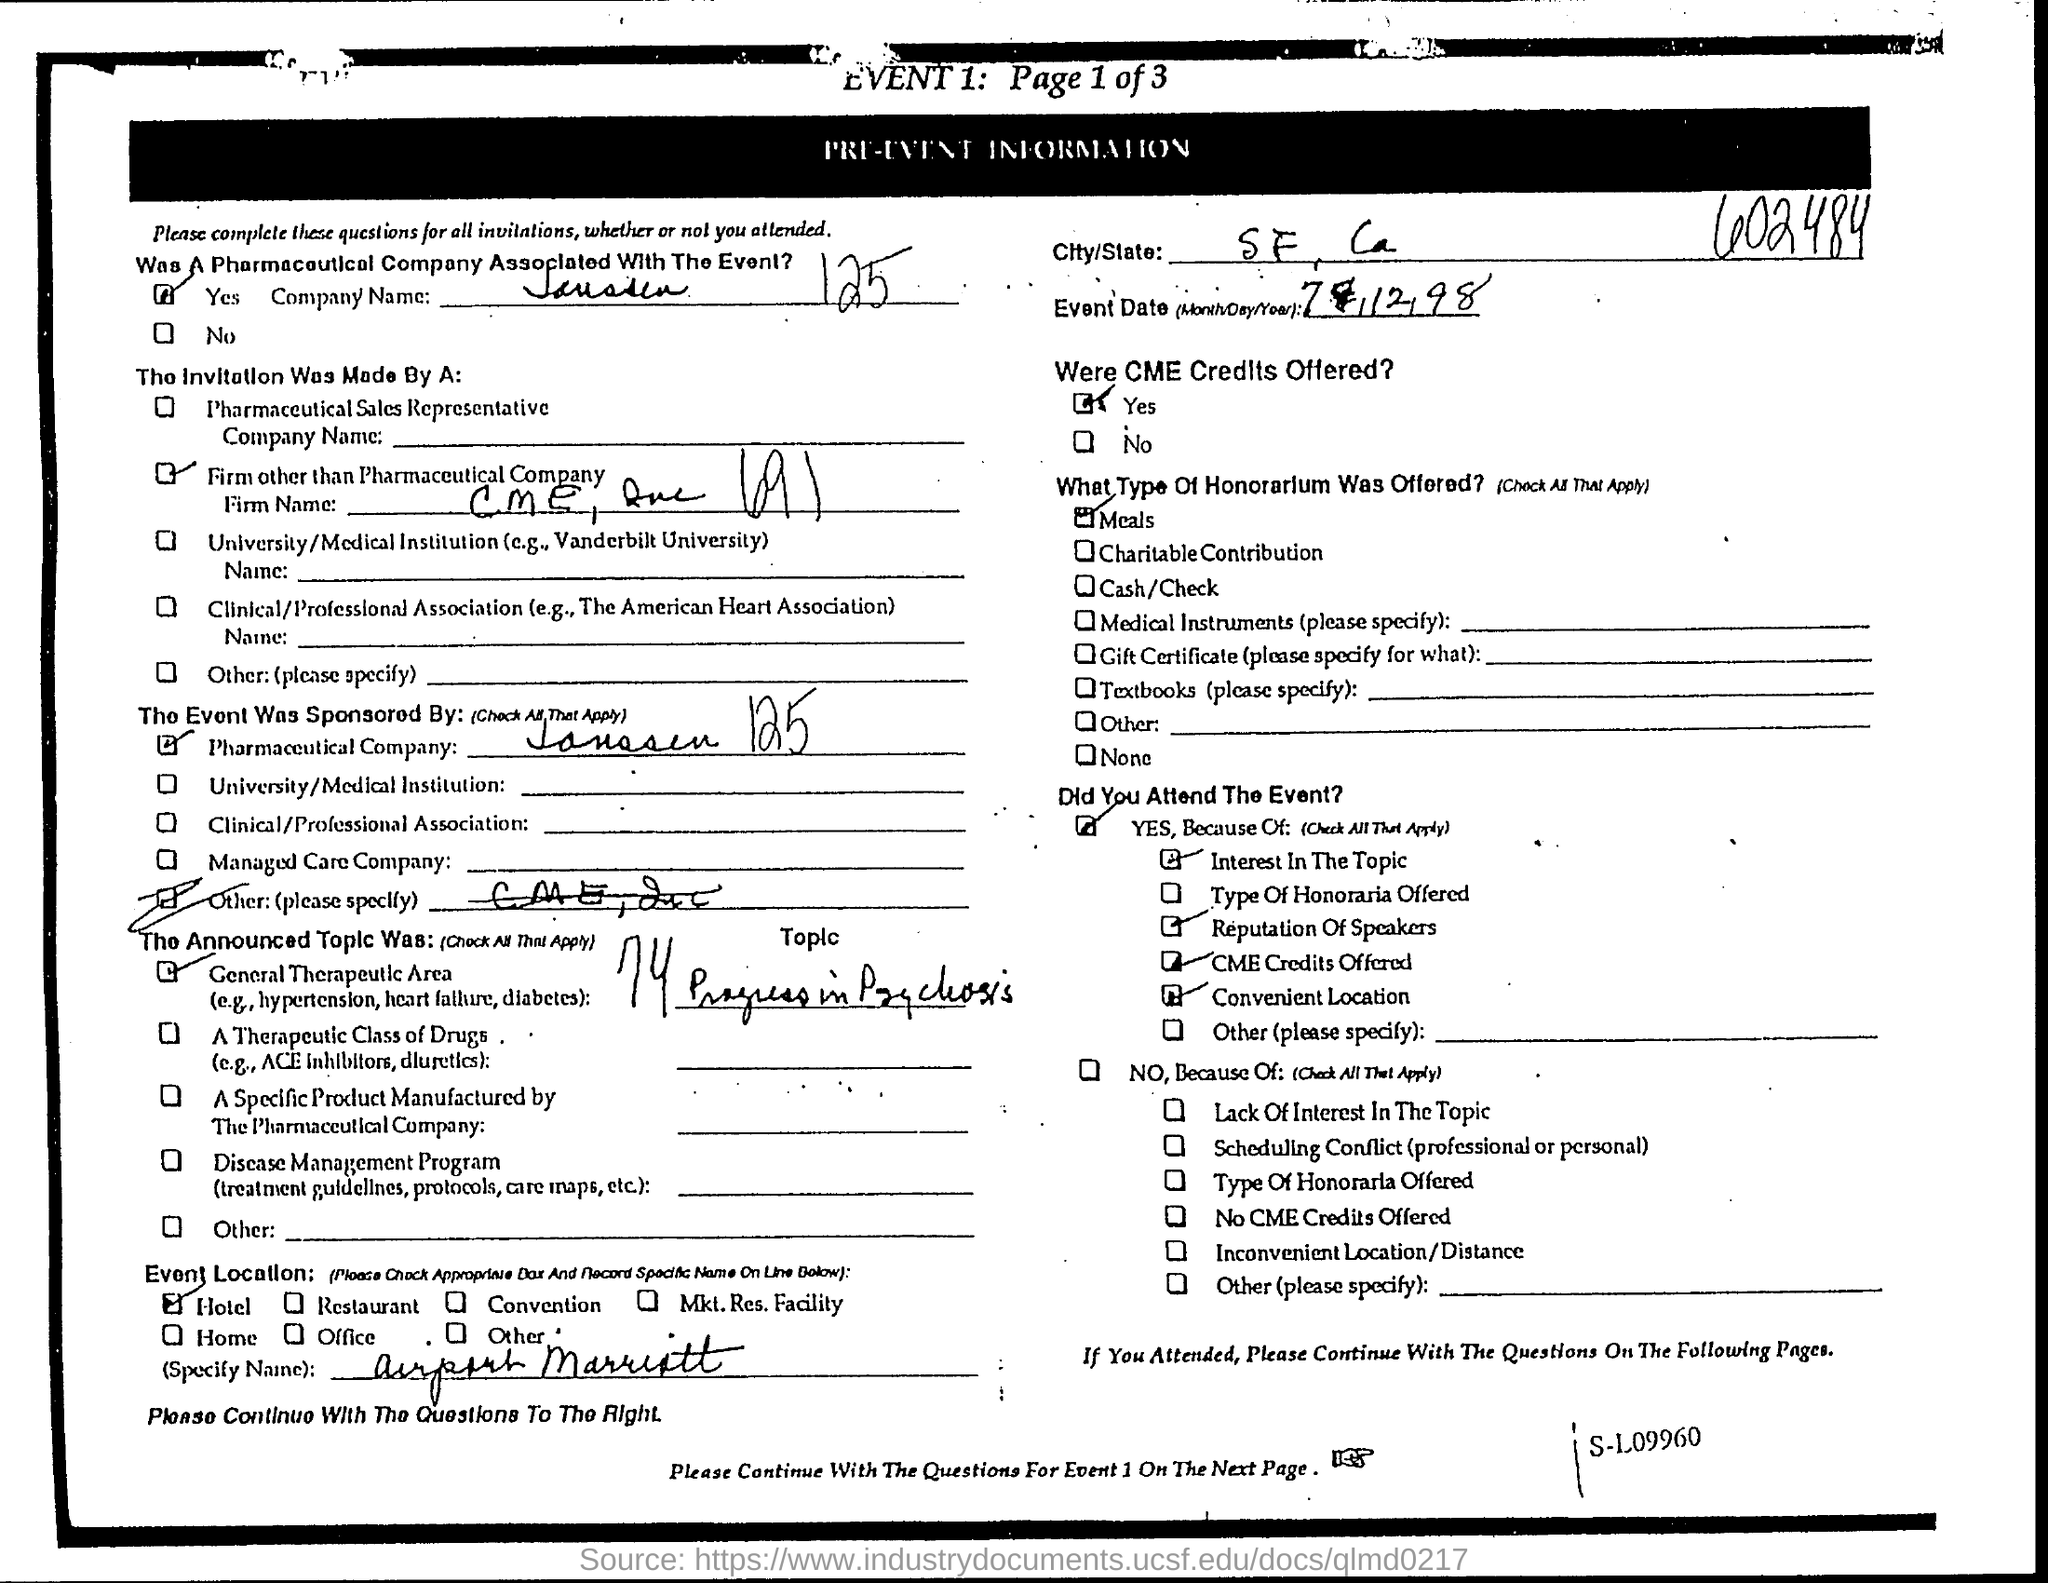Indicate a few pertinent items in this graphic. The Honorarium offered include meals. The page number provided is page 1 of 3. The city is San Francisco, located in the state of California. What is the event number?" is a question asking for information about an event. The sentence "1.." is not a complete question and does not provide enough information to answer it. To answer the question, more context is needed, such as the specific event being referred to and the context in which the question is being asked. The pharmaceutical company was associated with the event. 